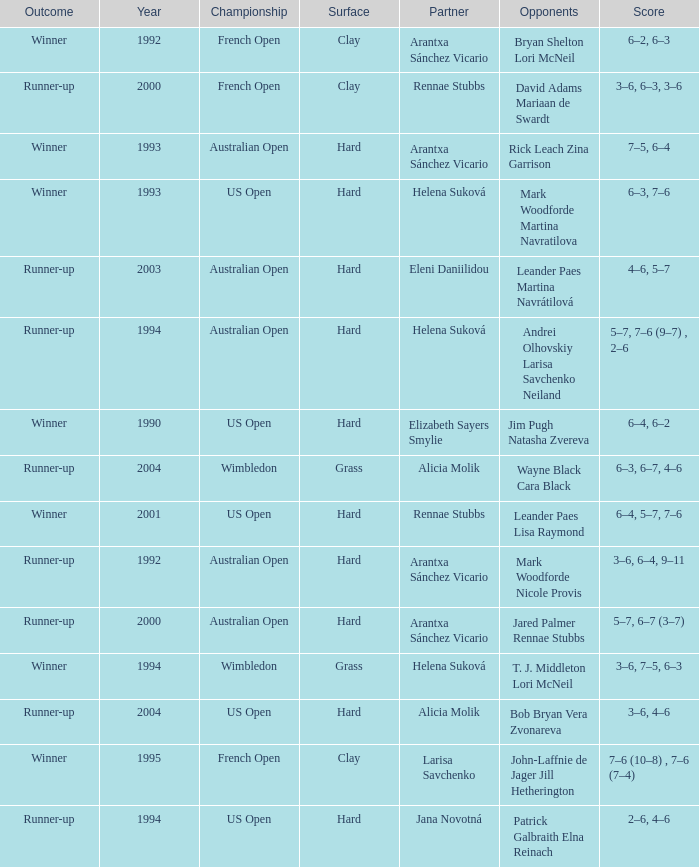Who was the Partner that was a winner, a Year smaller than 1993, and a Score of 6–4, 6–2? Elizabeth Sayers Smylie. 